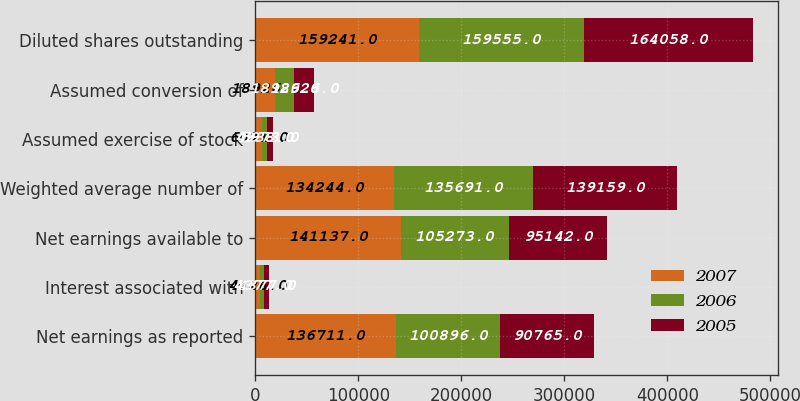<chart> <loc_0><loc_0><loc_500><loc_500><stacked_bar_chart><ecel><fcel>Net earnings as reported<fcel>Interest associated with<fcel>Net earnings available to<fcel>Weighted average number of<fcel>Assumed exercise of stock<fcel>Assumed conversion of<fcel>Diluted shares outstanding<nl><fcel>2007<fcel>136711<fcel>4426<fcel>141137<fcel>134244<fcel>6071<fcel>18926<fcel>159241<nl><fcel>2006<fcel>100896<fcel>4377<fcel>105273<fcel>135691<fcel>4938<fcel>18926<fcel>159555<nl><fcel>2005<fcel>90765<fcel>4377<fcel>95142<fcel>139159<fcel>5973<fcel>18926<fcel>164058<nl></chart> 